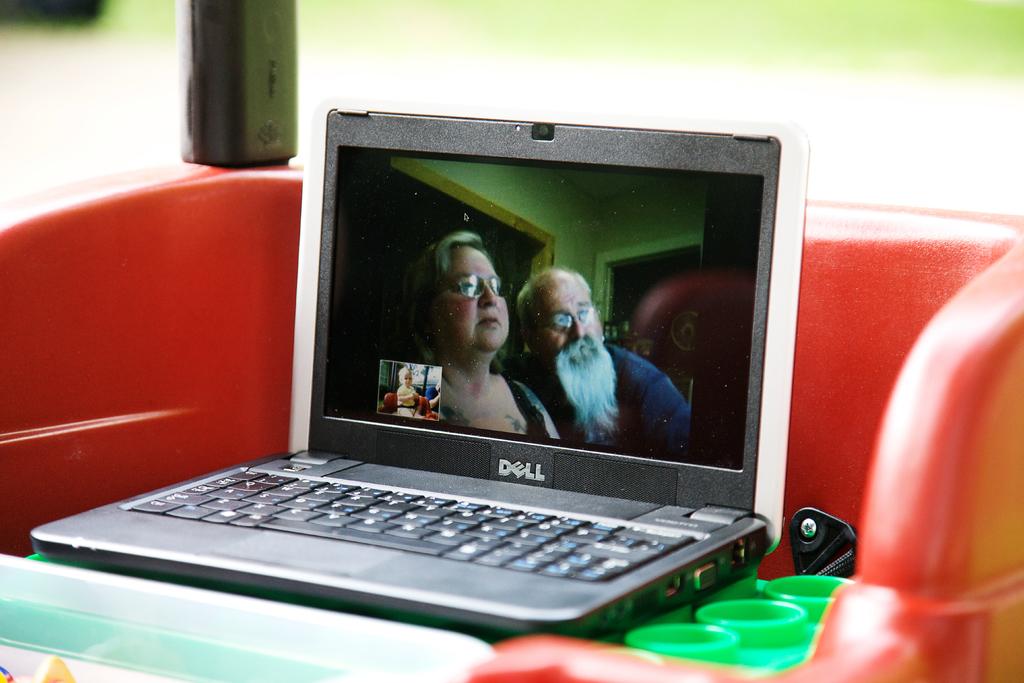What company makes the laptop?
Offer a terse response. Dell. 